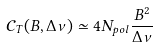Convert formula to latex. <formula><loc_0><loc_0><loc_500><loc_500>\mathcal { C } _ { T } ( B , \Delta \nu ) \simeq 4 N _ { p o l } \frac { B ^ { 2 } } { \Delta \nu }</formula> 